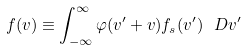<formula> <loc_0><loc_0><loc_500><loc_500>f ( v ) \equiv \int _ { - \infty } ^ { \infty } \varphi ( v ^ { \prime } + v ) f _ { s } ( v ^ { \prime } ) \ D { v ^ { \prime } }</formula> 